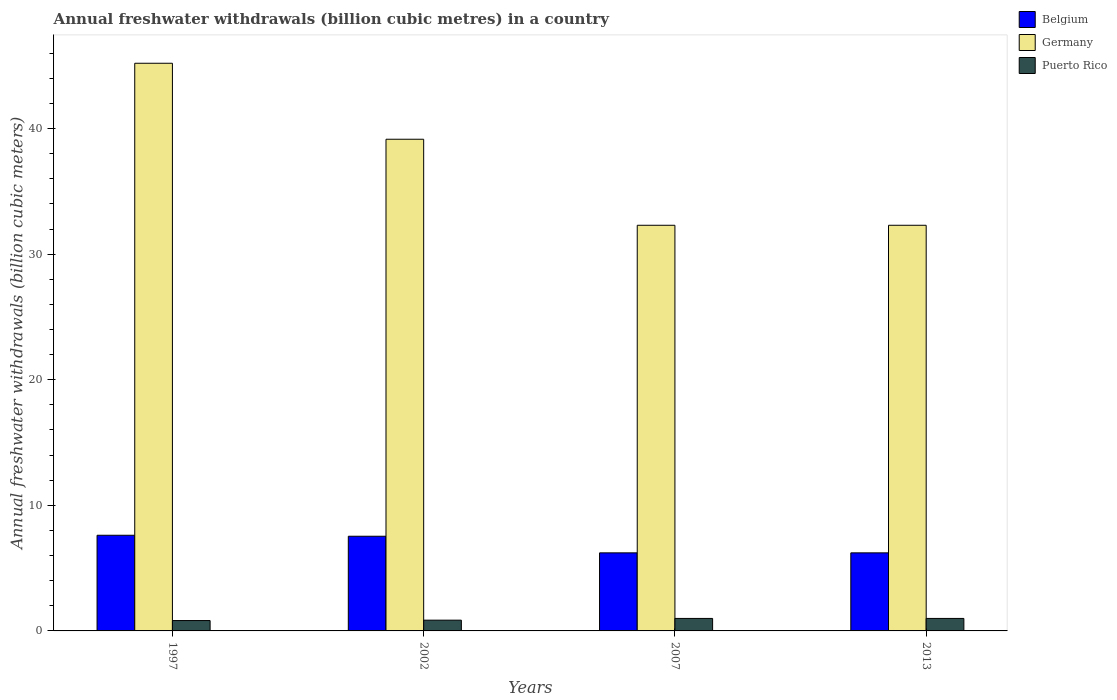How many different coloured bars are there?
Provide a succinct answer. 3. In how many cases, is the number of bars for a given year not equal to the number of legend labels?
Your answer should be very brief. 0. What is the annual freshwater withdrawals in Germany in 2013?
Keep it short and to the point. 32.3. Across all years, what is the minimum annual freshwater withdrawals in Puerto Rico?
Give a very brief answer. 0.83. In which year was the annual freshwater withdrawals in Puerto Rico maximum?
Keep it short and to the point. 2007. In which year was the annual freshwater withdrawals in Puerto Rico minimum?
Keep it short and to the point. 1997. What is the total annual freshwater withdrawals in Germany in the graph?
Keep it short and to the point. 148.95. What is the difference between the annual freshwater withdrawals in Belgium in 1997 and that in 2007?
Make the answer very short. 1.4. What is the difference between the annual freshwater withdrawals in Germany in 2007 and the annual freshwater withdrawals in Puerto Rico in 1997?
Make the answer very short. 31.47. What is the average annual freshwater withdrawals in Puerto Rico per year?
Offer a terse response. 0.92. In the year 2002, what is the difference between the annual freshwater withdrawals in Puerto Rico and annual freshwater withdrawals in Germany?
Provide a short and direct response. -38.29. In how many years, is the annual freshwater withdrawals in Belgium greater than 10 billion cubic meters?
Offer a terse response. 0. What is the ratio of the annual freshwater withdrawals in Puerto Rico in 1997 to that in 2013?
Keep it short and to the point. 0.83. Is the annual freshwater withdrawals in Puerto Rico in 1997 less than that in 2013?
Give a very brief answer. Yes. What is the difference between the highest and the lowest annual freshwater withdrawals in Belgium?
Offer a very short reply. 1.4. In how many years, is the annual freshwater withdrawals in Germany greater than the average annual freshwater withdrawals in Germany taken over all years?
Your answer should be very brief. 2. What does the 1st bar from the left in 2007 represents?
Your answer should be very brief. Belgium. What does the 1st bar from the right in 1997 represents?
Your answer should be very brief. Puerto Rico. How many bars are there?
Provide a short and direct response. 12. Are all the bars in the graph horizontal?
Provide a succinct answer. No. How many years are there in the graph?
Your answer should be very brief. 4. Does the graph contain grids?
Your answer should be compact. No. Where does the legend appear in the graph?
Your answer should be very brief. Top right. What is the title of the graph?
Your response must be concise. Annual freshwater withdrawals (billion cubic metres) in a country. Does "Madagascar" appear as one of the legend labels in the graph?
Make the answer very short. No. What is the label or title of the Y-axis?
Provide a short and direct response. Annual freshwater withdrawals (billion cubic meters). What is the Annual freshwater withdrawals (billion cubic meters) in Belgium in 1997?
Give a very brief answer. 7.62. What is the Annual freshwater withdrawals (billion cubic meters) of Germany in 1997?
Offer a terse response. 45.2. What is the Annual freshwater withdrawals (billion cubic meters) in Puerto Rico in 1997?
Offer a terse response. 0.83. What is the Annual freshwater withdrawals (billion cubic meters) of Belgium in 2002?
Provide a succinct answer. 7.54. What is the Annual freshwater withdrawals (billion cubic meters) of Germany in 2002?
Make the answer very short. 39.15. What is the Annual freshwater withdrawals (billion cubic meters) of Puerto Rico in 2002?
Ensure brevity in your answer.  0.86. What is the Annual freshwater withdrawals (billion cubic meters) in Belgium in 2007?
Provide a succinct answer. 6.22. What is the Annual freshwater withdrawals (billion cubic meters) in Germany in 2007?
Your answer should be very brief. 32.3. What is the Annual freshwater withdrawals (billion cubic meters) of Puerto Rico in 2007?
Make the answer very short. 0.99. What is the Annual freshwater withdrawals (billion cubic meters) in Belgium in 2013?
Give a very brief answer. 6.22. What is the Annual freshwater withdrawals (billion cubic meters) of Germany in 2013?
Give a very brief answer. 32.3. Across all years, what is the maximum Annual freshwater withdrawals (billion cubic meters) in Belgium?
Give a very brief answer. 7.62. Across all years, what is the maximum Annual freshwater withdrawals (billion cubic meters) of Germany?
Provide a short and direct response. 45.2. Across all years, what is the minimum Annual freshwater withdrawals (billion cubic meters) of Belgium?
Keep it short and to the point. 6.22. Across all years, what is the minimum Annual freshwater withdrawals (billion cubic meters) in Germany?
Offer a very short reply. 32.3. Across all years, what is the minimum Annual freshwater withdrawals (billion cubic meters) of Puerto Rico?
Provide a succinct answer. 0.83. What is the total Annual freshwater withdrawals (billion cubic meters) of Belgium in the graph?
Give a very brief answer. 27.59. What is the total Annual freshwater withdrawals (billion cubic meters) in Germany in the graph?
Keep it short and to the point. 148.95. What is the total Annual freshwater withdrawals (billion cubic meters) of Puerto Rico in the graph?
Offer a very short reply. 3.67. What is the difference between the Annual freshwater withdrawals (billion cubic meters) in Belgium in 1997 and that in 2002?
Your answer should be very brief. 0.08. What is the difference between the Annual freshwater withdrawals (billion cubic meters) of Germany in 1997 and that in 2002?
Your answer should be very brief. 6.05. What is the difference between the Annual freshwater withdrawals (billion cubic meters) in Puerto Rico in 1997 and that in 2002?
Offer a very short reply. -0.03. What is the difference between the Annual freshwater withdrawals (billion cubic meters) of Belgium in 1997 and that in 2007?
Your answer should be compact. 1.4. What is the difference between the Annual freshwater withdrawals (billion cubic meters) of Germany in 1997 and that in 2007?
Your answer should be very brief. 12.9. What is the difference between the Annual freshwater withdrawals (billion cubic meters) in Puerto Rico in 1997 and that in 2007?
Offer a very short reply. -0.17. What is the difference between the Annual freshwater withdrawals (billion cubic meters) in Belgium in 1997 and that in 2013?
Offer a very short reply. 1.4. What is the difference between the Annual freshwater withdrawals (billion cubic meters) in Puerto Rico in 1997 and that in 2013?
Provide a short and direct response. -0.17. What is the difference between the Annual freshwater withdrawals (billion cubic meters) of Belgium in 2002 and that in 2007?
Offer a terse response. 1.32. What is the difference between the Annual freshwater withdrawals (billion cubic meters) of Germany in 2002 and that in 2007?
Offer a very short reply. 6.85. What is the difference between the Annual freshwater withdrawals (billion cubic meters) of Puerto Rico in 2002 and that in 2007?
Your response must be concise. -0.14. What is the difference between the Annual freshwater withdrawals (billion cubic meters) of Belgium in 2002 and that in 2013?
Offer a terse response. 1.32. What is the difference between the Annual freshwater withdrawals (billion cubic meters) of Germany in 2002 and that in 2013?
Your response must be concise. 6.85. What is the difference between the Annual freshwater withdrawals (billion cubic meters) of Puerto Rico in 2002 and that in 2013?
Ensure brevity in your answer.  -0.14. What is the difference between the Annual freshwater withdrawals (billion cubic meters) in Belgium in 1997 and the Annual freshwater withdrawals (billion cubic meters) in Germany in 2002?
Your response must be concise. -31.53. What is the difference between the Annual freshwater withdrawals (billion cubic meters) of Belgium in 1997 and the Annual freshwater withdrawals (billion cubic meters) of Puerto Rico in 2002?
Your answer should be very brief. 6.76. What is the difference between the Annual freshwater withdrawals (billion cubic meters) of Germany in 1997 and the Annual freshwater withdrawals (billion cubic meters) of Puerto Rico in 2002?
Make the answer very short. 44.34. What is the difference between the Annual freshwater withdrawals (billion cubic meters) in Belgium in 1997 and the Annual freshwater withdrawals (billion cubic meters) in Germany in 2007?
Offer a very short reply. -24.68. What is the difference between the Annual freshwater withdrawals (billion cubic meters) in Belgium in 1997 and the Annual freshwater withdrawals (billion cubic meters) in Puerto Rico in 2007?
Provide a succinct answer. 6.62. What is the difference between the Annual freshwater withdrawals (billion cubic meters) in Germany in 1997 and the Annual freshwater withdrawals (billion cubic meters) in Puerto Rico in 2007?
Offer a very short reply. 44.2. What is the difference between the Annual freshwater withdrawals (billion cubic meters) of Belgium in 1997 and the Annual freshwater withdrawals (billion cubic meters) of Germany in 2013?
Ensure brevity in your answer.  -24.68. What is the difference between the Annual freshwater withdrawals (billion cubic meters) in Belgium in 1997 and the Annual freshwater withdrawals (billion cubic meters) in Puerto Rico in 2013?
Keep it short and to the point. 6.62. What is the difference between the Annual freshwater withdrawals (billion cubic meters) in Germany in 1997 and the Annual freshwater withdrawals (billion cubic meters) in Puerto Rico in 2013?
Your answer should be very brief. 44.2. What is the difference between the Annual freshwater withdrawals (billion cubic meters) of Belgium in 2002 and the Annual freshwater withdrawals (billion cubic meters) of Germany in 2007?
Your answer should be very brief. -24.76. What is the difference between the Annual freshwater withdrawals (billion cubic meters) in Belgium in 2002 and the Annual freshwater withdrawals (billion cubic meters) in Puerto Rico in 2007?
Your response must be concise. 6.54. What is the difference between the Annual freshwater withdrawals (billion cubic meters) of Germany in 2002 and the Annual freshwater withdrawals (billion cubic meters) of Puerto Rico in 2007?
Ensure brevity in your answer.  38.16. What is the difference between the Annual freshwater withdrawals (billion cubic meters) in Belgium in 2002 and the Annual freshwater withdrawals (billion cubic meters) in Germany in 2013?
Give a very brief answer. -24.76. What is the difference between the Annual freshwater withdrawals (billion cubic meters) in Belgium in 2002 and the Annual freshwater withdrawals (billion cubic meters) in Puerto Rico in 2013?
Make the answer very short. 6.54. What is the difference between the Annual freshwater withdrawals (billion cubic meters) in Germany in 2002 and the Annual freshwater withdrawals (billion cubic meters) in Puerto Rico in 2013?
Provide a short and direct response. 38.16. What is the difference between the Annual freshwater withdrawals (billion cubic meters) of Belgium in 2007 and the Annual freshwater withdrawals (billion cubic meters) of Germany in 2013?
Your response must be concise. -26.08. What is the difference between the Annual freshwater withdrawals (billion cubic meters) of Belgium in 2007 and the Annual freshwater withdrawals (billion cubic meters) of Puerto Rico in 2013?
Give a very brief answer. 5.22. What is the difference between the Annual freshwater withdrawals (billion cubic meters) in Germany in 2007 and the Annual freshwater withdrawals (billion cubic meters) in Puerto Rico in 2013?
Provide a short and direct response. 31.3. What is the average Annual freshwater withdrawals (billion cubic meters) of Belgium per year?
Ensure brevity in your answer.  6.9. What is the average Annual freshwater withdrawals (billion cubic meters) of Germany per year?
Offer a terse response. 37.24. What is the average Annual freshwater withdrawals (billion cubic meters) in Puerto Rico per year?
Your response must be concise. 0.92. In the year 1997, what is the difference between the Annual freshwater withdrawals (billion cubic meters) in Belgium and Annual freshwater withdrawals (billion cubic meters) in Germany?
Ensure brevity in your answer.  -37.58. In the year 1997, what is the difference between the Annual freshwater withdrawals (billion cubic meters) in Belgium and Annual freshwater withdrawals (billion cubic meters) in Puerto Rico?
Ensure brevity in your answer.  6.79. In the year 1997, what is the difference between the Annual freshwater withdrawals (billion cubic meters) of Germany and Annual freshwater withdrawals (billion cubic meters) of Puerto Rico?
Offer a very short reply. 44.37. In the year 2002, what is the difference between the Annual freshwater withdrawals (billion cubic meters) in Belgium and Annual freshwater withdrawals (billion cubic meters) in Germany?
Your response must be concise. -31.61. In the year 2002, what is the difference between the Annual freshwater withdrawals (billion cubic meters) of Belgium and Annual freshwater withdrawals (billion cubic meters) of Puerto Rico?
Your answer should be compact. 6.68. In the year 2002, what is the difference between the Annual freshwater withdrawals (billion cubic meters) of Germany and Annual freshwater withdrawals (billion cubic meters) of Puerto Rico?
Keep it short and to the point. 38.29. In the year 2007, what is the difference between the Annual freshwater withdrawals (billion cubic meters) in Belgium and Annual freshwater withdrawals (billion cubic meters) in Germany?
Your answer should be very brief. -26.08. In the year 2007, what is the difference between the Annual freshwater withdrawals (billion cubic meters) in Belgium and Annual freshwater withdrawals (billion cubic meters) in Puerto Rico?
Provide a succinct answer. 5.22. In the year 2007, what is the difference between the Annual freshwater withdrawals (billion cubic meters) of Germany and Annual freshwater withdrawals (billion cubic meters) of Puerto Rico?
Your answer should be very brief. 31.3. In the year 2013, what is the difference between the Annual freshwater withdrawals (billion cubic meters) of Belgium and Annual freshwater withdrawals (billion cubic meters) of Germany?
Make the answer very short. -26.08. In the year 2013, what is the difference between the Annual freshwater withdrawals (billion cubic meters) of Belgium and Annual freshwater withdrawals (billion cubic meters) of Puerto Rico?
Provide a short and direct response. 5.22. In the year 2013, what is the difference between the Annual freshwater withdrawals (billion cubic meters) of Germany and Annual freshwater withdrawals (billion cubic meters) of Puerto Rico?
Give a very brief answer. 31.3. What is the ratio of the Annual freshwater withdrawals (billion cubic meters) in Belgium in 1997 to that in 2002?
Your response must be concise. 1.01. What is the ratio of the Annual freshwater withdrawals (billion cubic meters) in Germany in 1997 to that in 2002?
Provide a succinct answer. 1.15. What is the ratio of the Annual freshwater withdrawals (billion cubic meters) of Puerto Rico in 1997 to that in 2002?
Provide a short and direct response. 0.96. What is the ratio of the Annual freshwater withdrawals (billion cubic meters) of Belgium in 1997 to that in 2007?
Offer a terse response. 1.23. What is the ratio of the Annual freshwater withdrawals (billion cubic meters) in Germany in 1997 to that in 2007?
Provide a succinct answer. 1.4. What is the ratio of the Annual freshwater withdrawals (billion cubic meters) of Puerto Rico in 1997 to that in 2007?
Your answer should be compact. 0.83. What is the ratio of the Annual freshwater withdrawals (billion cubic meters) of Belgium in 1997 to that in 2013?
Offer a very short reply. 1.23. What is the ratio of the Annual freshwater withdrawals (billion cubic meters) in Germany in 1997 to that in 2013?
Ensure brevity in your answer.  1.4. What is the ratio of the Annual freshwater withdrawals (billion cubic meters) in Puerto Rico in 1997 to that in 2013?
Your answer should be compact. 0.83. What is the ratio of the Annual freshwater withdrawals (billion cubic meters) of Belgium in 2002 to that in 2007?
Give a very brief answer. 1.21. What is the ratio of the Annual freshwater withdrawals (billion cubic meters) in Germany in 2002 to that in 2007?
Ensure brevity in your answer.  1.21. What is the ratio of the Annual freshwater withdrawals (billion cubic meters) in Puerto Rico in 2002 to that in 2007?
Provide a succinct answer. 0.86. What is the ratio of the Annual freshwater withdrawals (billion cubic meters) in Belgium in 2002 to that in 2013?
Make the answer very short. 1.21. What is the ratio of the Annual freshwater withdrawals (billion cubic meters) in Germany in 2002 to that in 2013?
Provide a succinct answer. 1.21. What is the ratio of the Annual freshwater withdrawals (billion cubic meters) in Puerto Rico in 2002 to that in 2013?
Offer a very short reply. 0.86. What is the ratio of the Annual freshwater withdrawals (billion cubic meters) of Belgium in 2007 to that in 2013?
Provide a succinct answer. 1. What is the ratio of the Annual freshwater withdrawals (billion cubic meters) of Puerto Rico in 2007 to that in 2013?
Provide a short and direct response. 1. What is the difference between the highest and the second highest Annual freshwater withdrawals (billion cubic meters) of Belgium?
Make the answer very short. 0.08. What is the difference between the highest and the second highest Annual freshwater withdrawals (billion cubic meters) in Germany?
Your answer should be compact. 6.05. What is the difference between the highest and the second highest Annual freshwater withdrawals (billion cubic meters) in Puerto Rico?
Keep it short and to the point. 0. What is the difference between the highest and the lowest Annual freshwater withdrawals (billion cubic meters) of Belgium?
Your response must be concise. 1.4. What is the difference between the highest and the lowest Annual freshwater withdrawals (billion cubic meters) in Puerto Rico?
Offer a terse response. 0.17. 